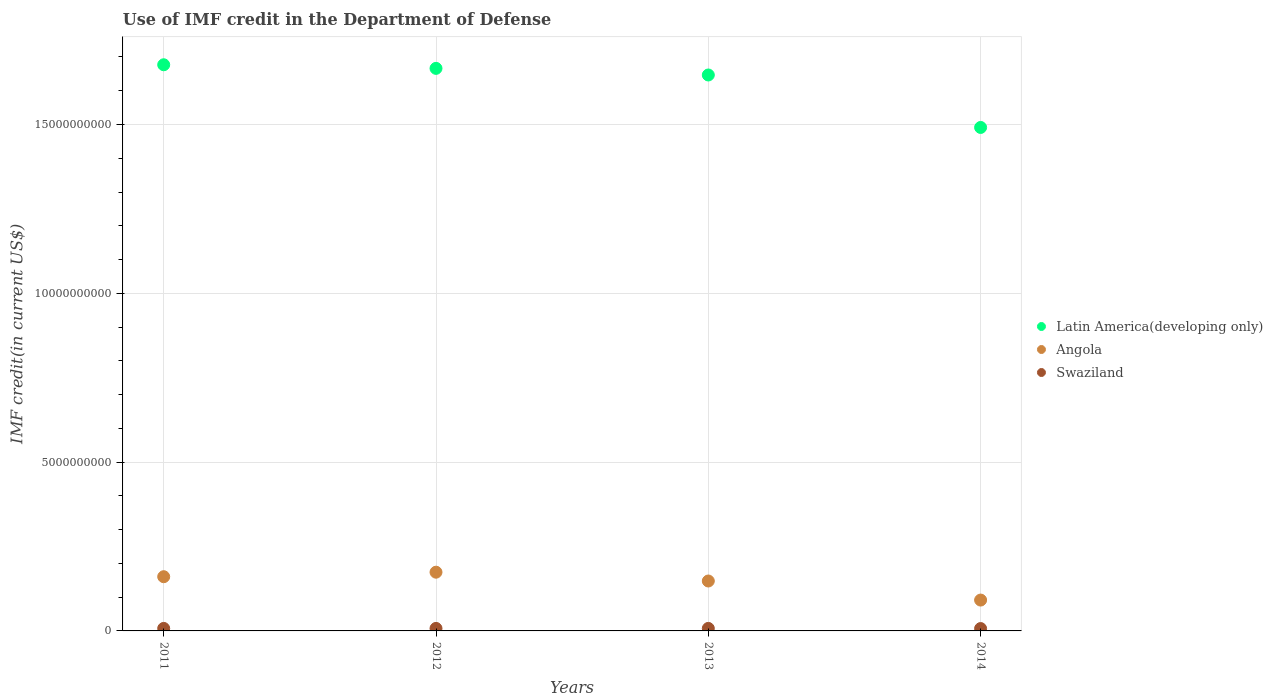Is the number of dotlines equal to the number of legend labels?
Your answer should be very brief. Yes. What is the IMF credit in the Department of Defense in Latin America(developing only) in 2012?
Give a very brief answer. 1.67e+1. Across all years, what is the maximum IMF credit in the Department of Defense in Swaziland?
Keep it short and to the point. 7.44e+07. Across all years, what is the minimum IMF credit in the Department of Defense in Latin America(developing only)?
Your response must be concise. 1.49e+1. In which year was the IMF credit in the Department of Defense in Latin America(developing only) maximum?
Your response must be concise. 2011. In which year was the IMF credit in the Department of Defense in Swaziland minimum?
Ensure brevity in your answer.  2014. What is the total IMF credit in the Department of Defense in Swaziland in the graph?
Give a very brief answer. 2.93e+08. What is the difference between the IMF credit in the Department of Defense in Swaziland in 2013 and that in 2014?
Keep it short and to the point. 4.40e+06. What is the difference between the IMF credit in the Department of Defense in Latin America(developing only) in 2014 and the IMF credit in the Department of Defense in Angola in 2012?
Make the answer very short. 1.32e+1. What is the average IMF credit in the Department of Defense in Angola per year?
Keep it short and to the point. 1.43e+09. In the year 2011, what is the difference between the IMF credit in the Department of Defense in Swaziland and IMF credit in the Department of Defense in Latin America(developing only)?
Ensure brevity in your answer.  -1.67e+1. What is the ratio of the IMF credit in the Department of Defense in Angola in 2011 to that in 2012?
Provide a succinct answer. 0.92. What is the difference between the highest and the second highest IMF credit in the Department of Defense in Angola?
Give a very brief answer. 1.34e+08. What is the difference between the highest and the lowest IMF credit in the Department of Defense in Latin America(developing only)?
Keep it short and to the point. 1.86e+09. In how many years, is the IMF credit in the Department of Defense in Latin America(developing only) greater than the average IMF credit in the Department of Defense in Latin America(developing only) taken over all years?
Ensure brevity in your answer.  3. Is the IMF credit in the Department of Defense in Swaziland strictly greater than the IMF credit in the Department of Defense in Latin America(developing only) over the years?
Provide a succinct answer. No. Is the IMF credit in the Department of Defense in Latin America(developing only) strictly less than the IMF credit in the Department of Defense in Swaziland over the years?
Ensure brevity in your answer.  No. Are the values on the major ticks of Y-axis written in scientific E-notation?
Provide a succinct answer. No. Does the graph contain grids?
Offer a very short reply. Yes. Where does the legend appear in the graph?
Offer a very short reply. Center right. How are the legend labels stacked?
Your answer should be compact. Vertical. What is the title of the graph?
Offer a very short reply. Use of IMF credit in the Department of Defense. Does "Chile" appear as one of the legend labels in the graph?
Provide a short and direct response. No. What is the label or title of the Y-axis?
Ensure brevity in your answer.  IMF credit(in current US$). What is the IMF credit(in current US$) of Latin America(developing only) in 2011?
Offer a very short reply. 1.68e+1. What is the IMF credit(in current US$) of Angola in 2011?
Offer a very short reply. 1.61e+09. What is the IMF credit(in current US$) of Swaziland in 2011?
Give a very brief answer. 7.41e+07. What is the IMF credit(in current US$) in Latin America(developing only) in 2012?
Ensure brevity in your answer.  1.67e+1. What is the IMF credit(in current US$) in Angola in 2012?
Offer a terse response. 1.74e+09. What is the IMF credit(in current US$) of Swaziland in 2012?
Offer a very short reply. 7.42e+07. What is the IMF credit(in current US$) in Latin America(developing only) in 2013?
Provide a succinct answer. 1.65e+1. What is the IMF credit(in current US$) of Angola in 2013?
Your response must be concise. 1.48e+09. What is the IMF credit(in current US$) of Swaziland in 2013?
Your answer should be compact. 7.44e+07. What is the IMF credit(in current US$) in Latin America(developing only) in 2014?
Your answer should be compact. 1.49e+1. What is the IMF credit(in current US$) in Angola in 2014?
Provide a succinct answer. 9.14e+08. What is the IMF credit(in current US$) in Swaziland in 2014?
Make the answer very short. 7.00e+07. Across all years, what is the maximum IMF credit(in current US$) in Latin America(developing only)?
Offer a very short reply. 1.68e+1. Across all years, what is the maximum IMF credit(in current US$) in Angola?
Keep it short and to the point. 1.74e+09. Across all years, what is the maximum IMF credit(in current US$) of Swaziland?
Keep it short and to the point. 7.44e+07. Across all years, what is the minimum IMF credit(in current US$) in Latin America(developing only)?
Provide a short and direct response. 1.49e+1. Across all years, what is the minimum IMF credit(in current US$) of Angola?
Provide a succinct answer. 9.14e+08. Across all years, what is the minimum IMF credit(in current US$) of Swaziland?
Your answer should be compact. 7.00e+07. What is the total IMF credit(in current US$) in Latin America(developing only) in the graph?
Keep it short and to the point. 6.48e+1. What is the total IMF credit(in current US$) in Angola in the graph?
Your answer should be compact. 5.74e+09. What is the total IMF credit(in current US$) of Swaziland in the graph?
Your answer should be compact. 2.93e+08. What is the difference between the IMF credit(in current US$) of Latin America(developing only) in 2011 and that in 2012?
Your response must be concise. 1.07e+08. What is the difference between the IMF credit(in current US$) in Angola in 2011 and that in 2012?
Keep it short and to the point. -1.34e+08. What is the difference between the IMF credit(in current US$) of Latin America(developing only) in 2011 and that in 2013?
Your answer should be very brief. 3.03e+08. What is the difference between the IMF credit(in current US$) of Angola in 2011 and that in 2013?
Make the answer very short. 1.27e+08. What is the difference between the IMF credit(in current US$) in Swaziland in 2011 and that in 2013?
Your response must be concise. -2.28e+05. What is the difference between the IMF credit(in current US$) in Latin America(developing only) in 2011 and that in 2014?
Your answer should be compact. 1.86e+09. What is the difference between the IMF credit(in current US$) of Angola in 2011 and that in 2014?
Make the answer very short. 6.92e+08. What is the difference between the IMF credit(in current US$) of Swaziland in 2011 and that in 2014?
Keep it short and to the point. 4.17e+06. What is the difference between the IMF credit(in current US$) of Latin America(developing only) in 2012 and that in 2013?
Make the answer very short. 1.96e+08. What is the difference between the IMF credit(in current US$) in Angola in 2012 and that in 2013?
Provide a short and direct response. 2.61e+08. What is the difference between the IMF credit(in current US$) of Swaziland in 2012 and that in 2013?
Your answer should be very brief. -1.48e+05. What is the difference between the IMF credit(in current US$) of Latin America(developing only) in 2012 and that in 2014?
Offer a very short reply. 1.75e+09. What is the difference between the IMF credit(in current US$) of Angola in 2012 and that in 2014?
Your answer should be very brief. 8.26e+08. What is the difference between the IMF credit(in current US$) of Swaziland in 2012 and that in 2014?
Your answer should be compact. 4.25e+06. What is the difference between the IMF credit(in current US$) in Latin America(developing only) in 2013 and that in 2014?
Your answer should be compact. 1.55e+09. What is the difference between the IMF credit(in current US$) of Angola in 2013 and that in 2014?
Provide a short and direct response. 5.65e+08. What is the difference between the IMF credit(in current US$) of Swaziland in 2013 and that in 2014?
Your answer should be compact. 4.40e+06. What is the difference between the IMF credit(in current US$) of Latin America(developing only) in 2011 and the IMF credit(in current US$) of Angola in 2012?
Your answer should be compact. 1.50e+1. What is the difference between the IMF credit(in current US$) in Latin America(developing only) in 2011 and the IMF credit(in current US$) in Swaziland in 2012?
Your answer should be very brief. 1.67e+1. What is the difference between the IMF credit(in current US$) of Angola in 2011 and the IMF credit(in current US$) of Swaziland in 2012?
Give a very brief answer. 1.53e+09. What is the difference between the IMF credit(in current US$) of Latin America(developing only) in 2011 and the IMF credit(in current US$) of Angola in 2013?
Offer a very short reply. 1.53e+1. What is the difference between the IMF credit(in current US$) in Latin America(developing only) in 2011 and the IMF credit(in current US$) in Swaziland in 2013?
Ensure brevity in your answer.  1.67e+1. What is the difference between the IMF credit(in current US$) in Angola in 2011 and the IMF credit(in current US$) in Swaziland in 2013?
Offer a very short reply. 1.53e+09. What is the difference between the IMF credit(in current US$) of Latin America(developing only) in 2011 and the IMF credit(in current US$) of Angola in 2014?
Your answer should be very brief. 1.59e+1. What is the difference between the IMF credit(in current US$) in Latin America(developing only) in 2011 and the IMF credit(in current US$) in Swaziland in 2014?
Provide a short and direct response. 1.67e+1. What is the difference between the IMF credit(in current US$) of Angola in 2011 and the IMF credit(in current US$) of Swaziland in 2014?
Your response must be concise. 1.54e+09. What is the difference between the IMF credit(in current US$) of Latin America(developing only) in 2012 and the IMF credit(in current US$) of Angola in 2013?
Offer a terse response. 1.52e+1. What is the difference between the IMF credit(in current US$) of Latin America(developing only) in 2012 and the IMF credit(in current US$) of Swaziland in 2013?
Your answer should be compact. 1.66e+1. What is the difference between the IMF credit(in current US$) of Angola in 2012 and the IMF credit(in current US$) of Swaziland in 2013?
Offer a terse response. 1.67e+09. What is the difference between the IMF credit(in current US$) in Latin America(developing only) in 2012 and the IMF credit(in current US$) in Angola in 2014?
Your answer should be compact. 1.57e+1. What is the difference between the IMF credit(in current US$) in Latin America(developing only) in 2012 and the IMF credit(in current US$) in Swaziland in 2014?
Your answer should be very brief. 1.66e+1. What is the difference between the IMF credit(in current US$) in Angola in 2012 and the IMF credit(in current US$) in Swaziland in 2014?
Offer a terse response. 1.67e+09. What is the difference between the IMF credit(in current US$) in Latin America(developing only) in 2013 and the IMF credit(in current US$) in Angola in 2014?
Offer a terse response. 1.56e+1. What is the difference between the IMF credit(in current US$) of Latin America(developing only) in 2013 and the IMF credit(in current US$) of Swaziland in 2014?
Keep it short and to the point. 1.64e+1. What is the difference between the IMF credit(in current US$) in Angola in 2013 and the IMF credit(in current US$) in Swaziland in 2014?
Ensure brevity in your answer.  1.41e+09. What is the average IMF credit(in current US$) of Latin America(developing only) per year?
Offer a terse response. 1.62e+1. What is the average IMF credit(in current US$) in Angola per year?
Offer a very short reply. 1.43e+09. What is the average IMF credit(in current US$) in Swaziland per year?
Your answer should be very brief. 7.32e+07. In the year 2011, what is the difference between the IMF credit(in current US$) of Latin America(developing only) and IMF credit(in current US$) of Angola?
Make the answer very short. 1.52e+1. In the year 2011, what is the difference between the IMF credit(in current US$) in Latin America(developing only) and IMF credit(in current US$) in Swaziland?
Your answer should be compact. 1.67e+1. In the year 2011, what is the difference between the IMF credit(in current US$) of Angola and IMF credit(in current US$) of Swaziland?
Provide a succinct answer. 1.53e+09. In the year 2012, what is the difference between the IMF credit(in current US$) of Latin America(developing only) and IMF credit(in current US$) of Angola?
Give a very brief answer. 1.49e+1. In the year 2012, what is the difference between the IMF credit(in current US$) of Latin America(developing only) and IMF credit(in current US$) of Swaziland?
Offer a terse response. 1.66e+1. In the year 2012, what is the difference between the IMF credit(in current US$) in Angola and IMF credit(in current US$) in Swaziland?
Keep it short and to the point. 1.67e+09. In the year 2013, what is the difference between the IMF credit(in current US$) in Latin America(developing only) and IMF credit(in current US$) in Angola?
Your answer should be very brief. 1.50e+1. In the year 2013, what is the difference between the IMF credit(in current US$) of Latin America(developing only) and IMF credit(in current US$) of Swaziland?
Keep it short and to the point. 1.64e+1. In the year 2013, what is the difference between the IMF credit(in current US$) in Angola and IMF credit(in current US$) in Swaziland?
Your answer should be very brief. 1.40e+09. In the year 2014, what is the difference between the IMF credit(in current US$) of Latin America(developing only) and IMF credit(in current US$) of Angola?
Ensure brevity in your answer.  1.40e+1. In the year 2014, what is the difference between the IMF credit(in current US$) of Latin America(developing only) and IMF credit(in current US$) of Swaziland?
Your answer should be compact. 1.48e+1. In the year 2014, what is the difference between the IMF credit(in current US$) of Angola and IMF credit(in current US$) of Swaziland?
Provide a short and direct response. 8.44e+08. What is the ratio of the IMF credit(in current US$) in Latin America(developing only) in 2011 to that in 2012?
Provide a short and direct response. 1.01. What is the ratio of the IMF credit(in current US$) in Angola in 2011 to that in 2012?
Your answer should be very brief. 0.92. What is the ratio of the IMF credit(in current US$) of Latin America(developing only) in 2011 to that in 2013?
Ensure brevity in your answer.  1.02. What is the ratio of the IMF credit(in current US$) in Angola in 2011 to that in 2013?
Provide a short and direct response. 1.09. What is the ratio of the IMF credit(in current US$) in Latin America(developing only) in 2011 to that in 2014?
Your answer should be compact. 1.12. What is the ratio of the IMF credit(in current US$) in Angola in 2011 to that in 2014?
Your answer should be compact. 1.76. What is the ratio of the IMF credit(in current US$) in Swaziland in 2011 to that in 2014?
Offer a very short reply. 1.06. What is the ratio of the IMF credit(in current US$) in Latin America(developing only) in 2012 to that in 2013?
Keep it short and to the point. 1.01. What is the ratio of the IMF credit(in current US$) in Angola in 2012 to that in 2013?
Ensure brevity in your answer.  1.18. What is the ratio of the IMF credit(in current US$) of Latin America(developing only) in 2012 to that in 2014?
Provide a short and direct response. 1.12. What is the ratio of the IMF credit(in current US$) of Angola in 2012 to that in 2014?
Make the answer very short. 1.9. What is the ratio of the IMF credit(in current US$) of Swaziland in 2012 to that in 2014?
Provide a short and direct response. 1.06. What is the ratio of the IMF credit(in current US$) in Latin America(developing only) in 2013 to that in 2014?
Your response must be concise. 1.1. What is the ratio of the IMF credit(in current US$) of Angola in 2013 to that in 2014?
Give a very brief answer. 1.62. What is the ratio of the IMF credit(in current US$) of Swaziland in 2013 to that in 2014?
Provide a succinct answer. 1.06. What is the difference between the highest and the second highest IMF credit(in current US$) of Latin America(developing only)?
Give a very brief answer. 1.07e+08. What is the difference between the highest and the second highest IMF credit(in current US$) in Angola?
Keep it short and to the point. 1.34e+08. What is the difference between the highest and the second highest IMF credit(in current US$) in Swaziland?
Your answer should be very brief. 1.48e+05. What is the difference between the highest and the lowest IMF credit(in current US$) in Latin America(developing only)?
Ensure brevity in your answer.  1.86e+09. What is the difference between the highest and the lowest IMF credit(in current US$) of Angola?
Make the answer very short. 8.26e+08. What is the difference between the highest and the lowest IMF credit(in current US$) of Swaziland?
Your answer should be compact. 4.40e+06. 